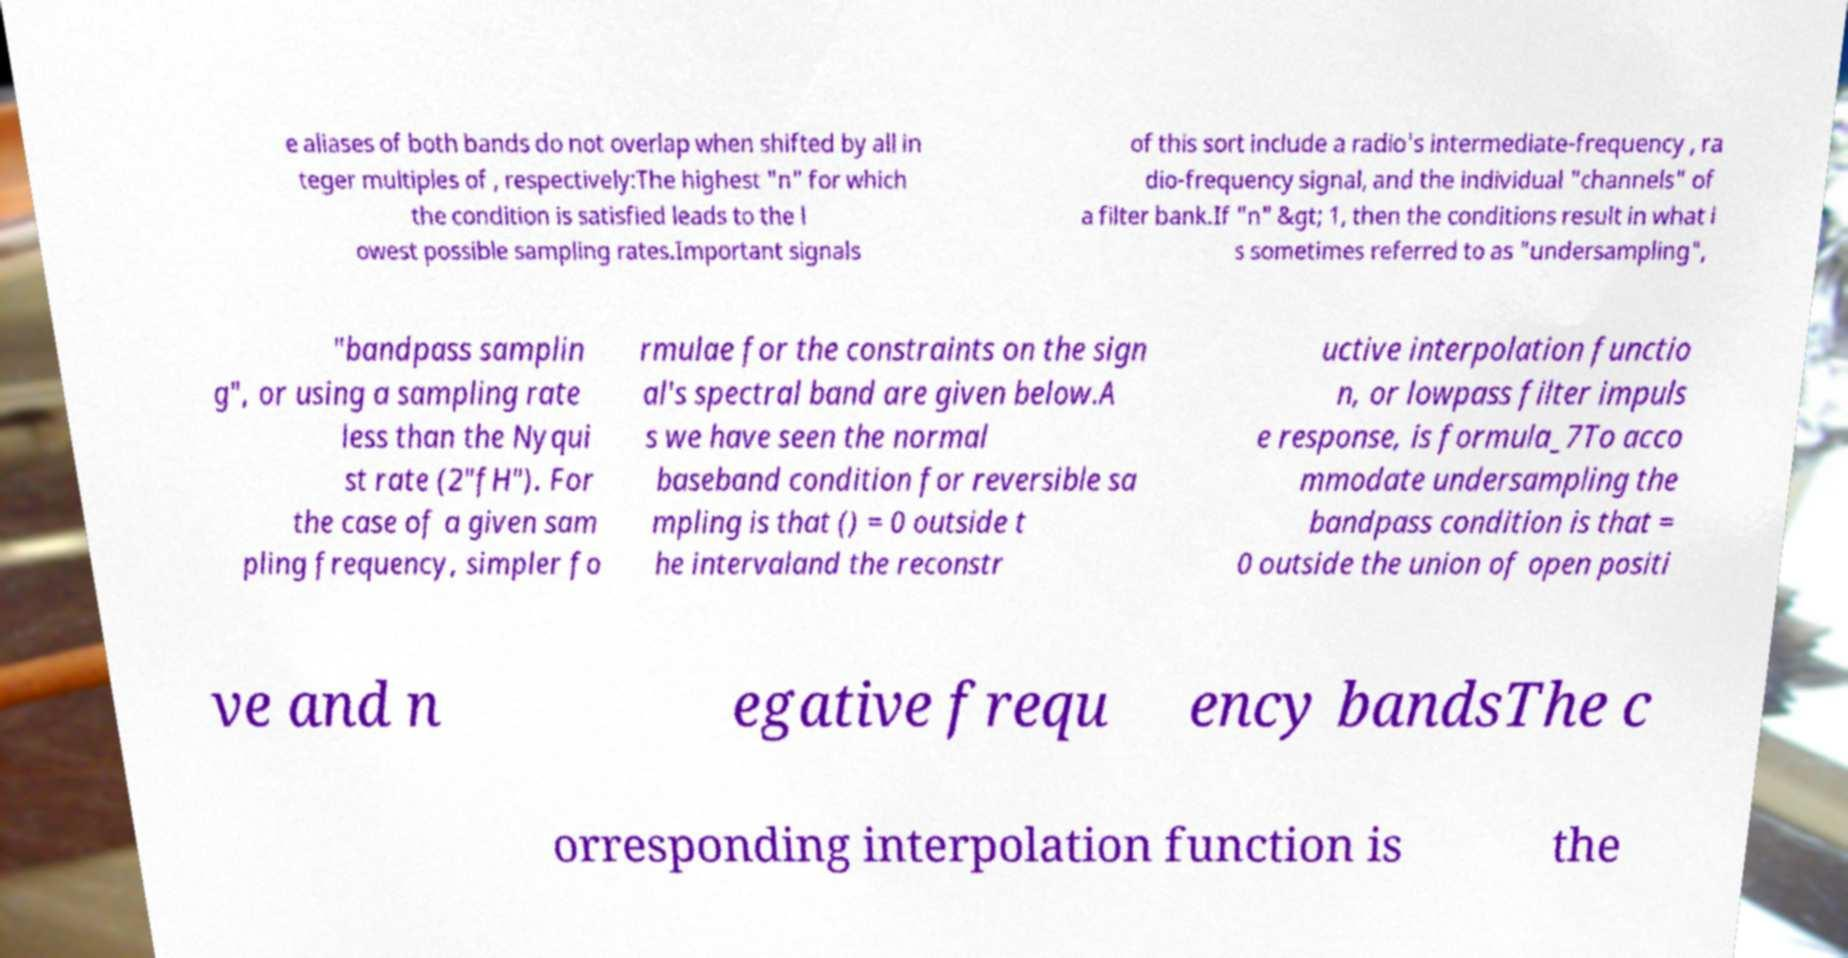Please identify and transcribe the text found in this image. e aliases of both bands do not overlap when shifted by all in teger multiples of , respectively:The highest "n" for which the condition is satisfied leads to the l owest possible sampling rates.Important signals of this sort include a radio's intermediate-frequency , ra dio-frequency signal, and the individual "channels" of a filter bank.If "n" &gt; 1, then the conditions result in what i s sometimes referred to as "undersampling", "bandpass samplin g", or using a sampling rate less than the Nyqui st rate (2"fH"). For the case of a given sam pling frequency, simpler fo rmulae for the constraints on the sign al's spectral band are given below.A s we have seen the normal baseband condition for reversible sa mpling is that () = 0 outside t he intervaland the reconstr uctive interpolation functio n, or lowpass filter impuls e response, is formula_7To acco mmodate undersampling the bandpass condition is that = 0 outside the union of open positi ve and n egative frequ ency bandsThe c orresponding interpolation function is the 